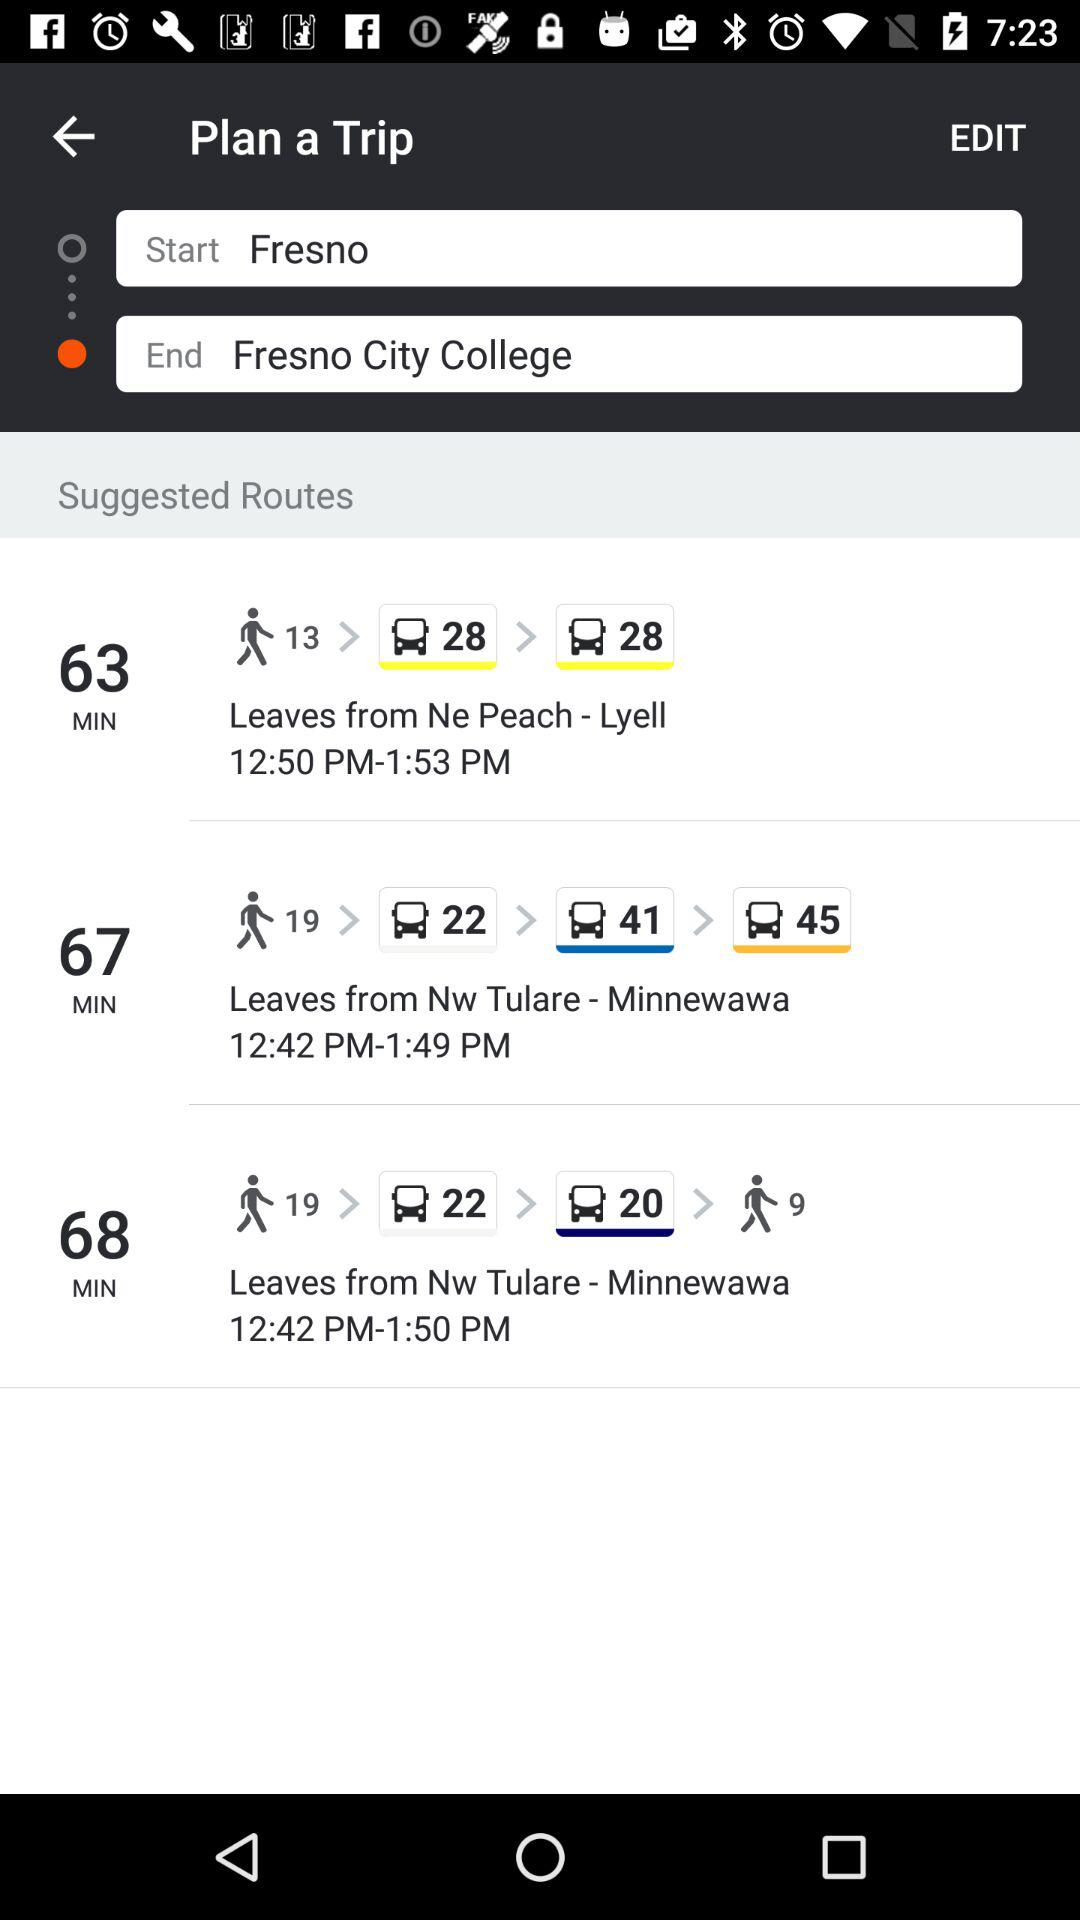What is the starting location? The starting location is Frenso. 